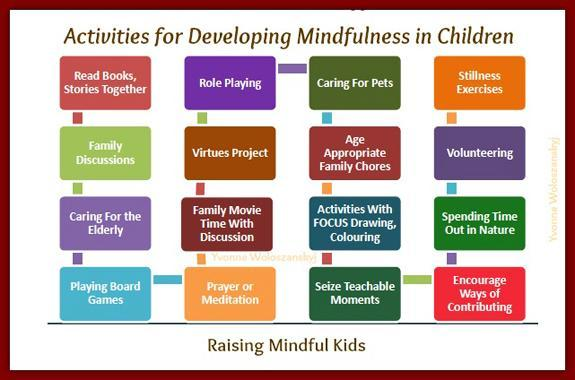What recommendation is being made for Family chores?
Answer the question with a short phrase. age appropriate family chores How many number of activities for developing mindfulness in children have been listed in the infographic? 16 